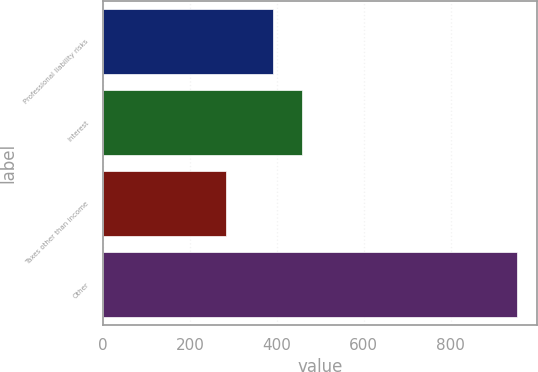Convert chart to OTSL. <chart><loc_0><loc_0><loc_500><loc_500><bar_chart><fcel>Professional liability risks<fcel>Interest<fcel>Taxes other than income<fcel>Other<nl><fcel>391<fcel>457.9<fcel>283<fcel>952<nl></chart> 